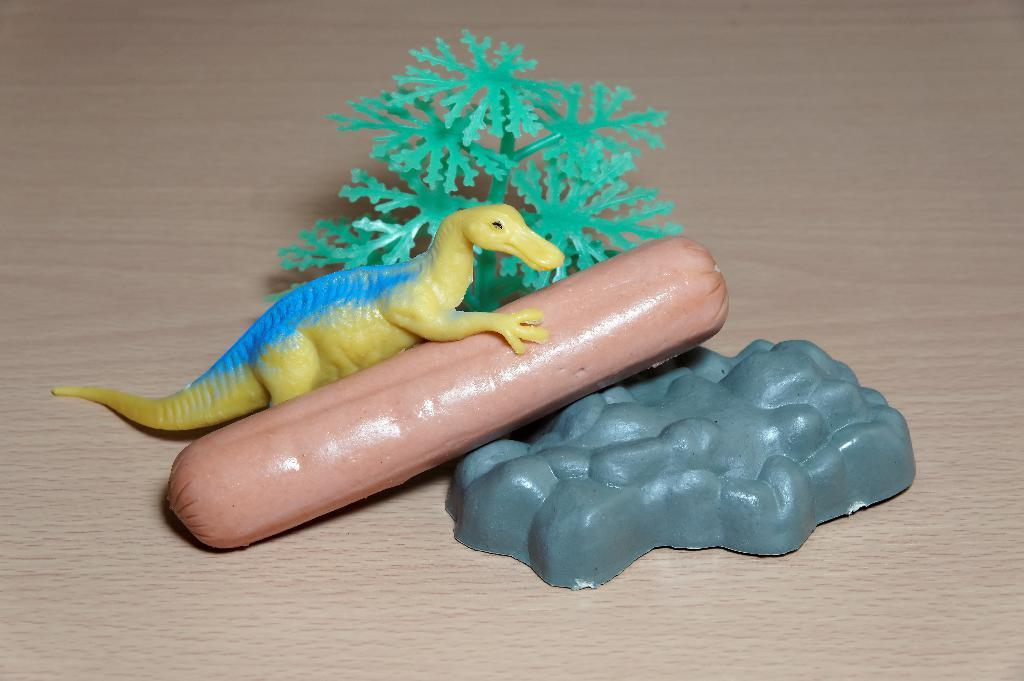What objects are present in the image that are typically associated with play? There are toys in the image. What type of plant is visible in the image? There is a green tree in the image. Where are the toys and the green tree placed in the image? The toys and the green tree are placed on a wooden table top. What type of transport can be seen in the image? There is no transport visible in the image; it features toys and a green tree on a wooden table top. What type of coil is wrapped around the green tree in the image? There is no coil present in the image; it only features toys and a green tree on a wooden table top. 